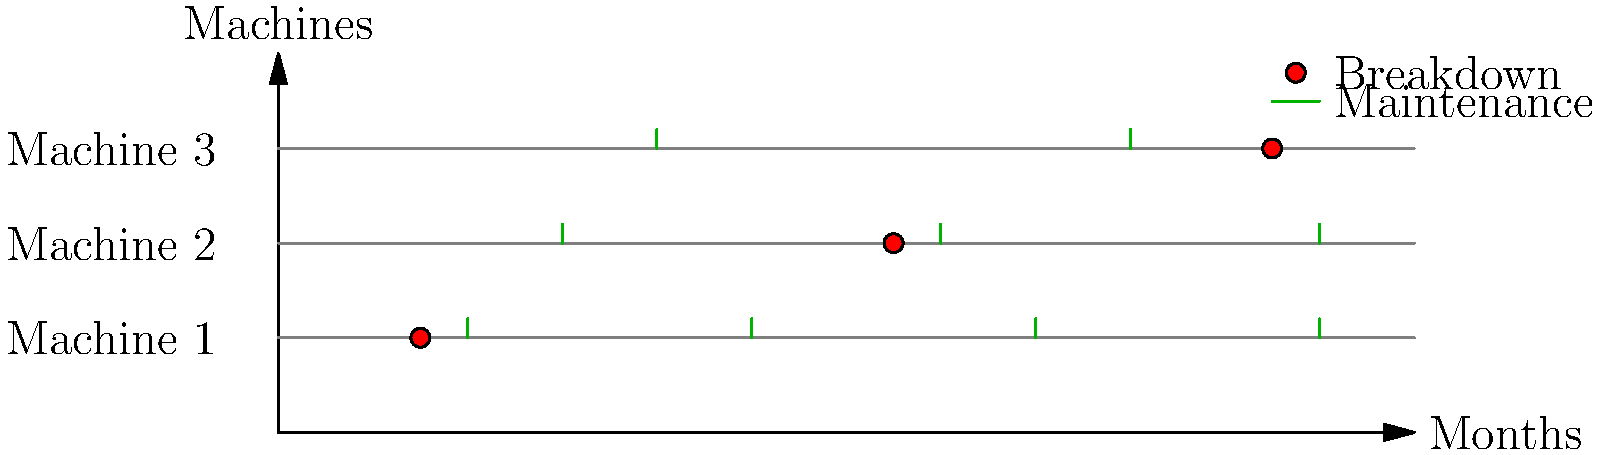Based on the equipment maintenance timeline shown, which machine requires the most frequent maintenance and what is its maintenance interval in months? To determine which machine requires the most frequent maintenance and its interval, let's analyze the timeline for each machine:

1. Machine 1:
   - Maintenance points: 2, 5, 8, 11 months
   - Interval: 3 months

2. Machine 2:
   - Maintenance points: 3, 7, 11 months
   - Interval: 4 months

3. Machine 3:
   - Maintenance points: 4, 9 months
   - Interval: 5 months

Comparing the intervals:
- Machine 1: 3 months
- Machine 2: 4 months
- Machine 3: 5 months

Machine 1 has the shortest interval between maintenance points, which means it requires the most frequent maintenance.

The maintenance interval for Machine 1 is 3 months.
Answer: Machine 1, 3 months 